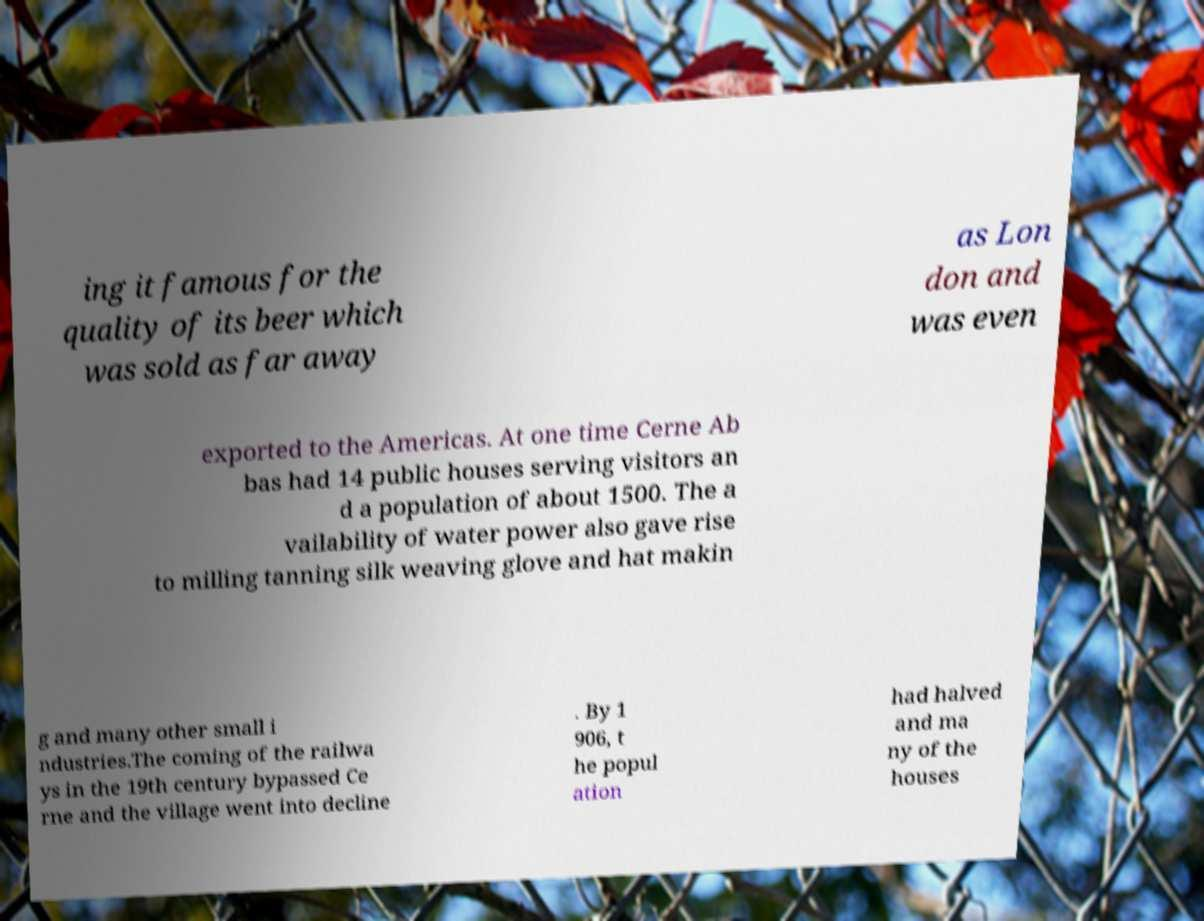Could you assist in decoding the text presented in this image and type it out clearly? ing it famous for the quality of its beer which was sold as far away as Lon don and was even exported to the Americas. At one time Cerne Ab bas had 14 public houses serving visitors an d a population of about 1500. The a vailability of water power also gave rise to milling tanning silk weaving glove and hat makin g and many other small i ndustries.The coming of the railwa ys in the 19th century bypassed Ce rne and the village went into decline . By 1 906, t he popul ation had halved and ma ny of the houses 